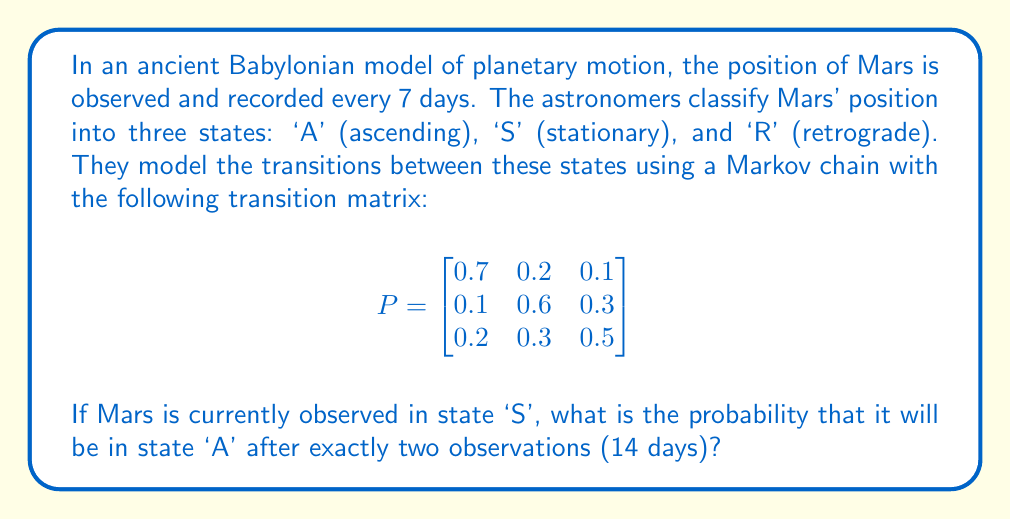What is the answer to this math problem? To solve this problem, we need to use the Chapman-Kolmogorov equations for Markov chains. We want to find the probability of transitioning from state 'S' to state 'A' in two steps.

Step 1: Identify the initial state vector.
Since Mars starts in state 'S', our initial state vector is:
$$v_0 = \begin{bmatrix} 0 & 1 & 0 \end{bmatrix}$$

Step 2: Calculate the two-step transition matrix.
We need to multiply the transition matrix by itself:
$$P^2 = P \times P = \begin{bmatrix}
0.7 & 0.2 & 0.1 \\
0.1 & 0.6 & 0.3 \\
0.2 & 0.3 & 0.5
\end{bmatrix} \times \begin{bmatrix}
0.7 & 0.2 & 0.1 \\
0.1 & 0.6 & 0.3 \\
0.2 & 0.3 & 0.5
\end{bmatrix}$$

Step 3: Perform the matrix multiplication.
$$P^2 = \begin{bmatrix}
0.53 & 0.29 & 0.18 \\
0.22 & 0.48 & 0.30 \\
0.27 & 0.39 & 0.34
\end{bmatrix}$$

Step 4: Find the probability of transitioning from 'S' to 'A' in two steps.
This is the element in the second row (representing the initial 'S' state) and first column (representing the final 'A' state) of the $P^2$ matrix.

The probability is 0.22 or 22%.
Answer: 0.22 